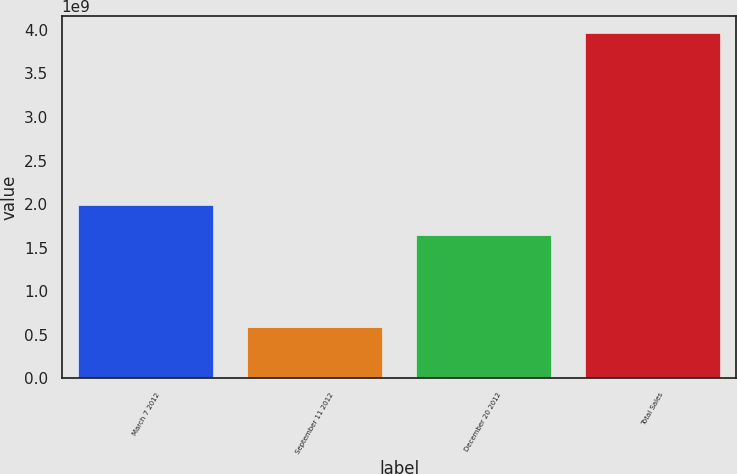Convert chart to OTSL. <chart><loc_0><loc_0><loc_500><loc_500><bar_chart><fcel>March 7 2012<fcel>September 11 2012<fcel>December 20 2012<fcel>Total Sales<nl><fcel>1.98579e+09<fcel>5.91866e+08<fcel>1.6489e+09<fcel>3.96077e+09<nl></chart> 